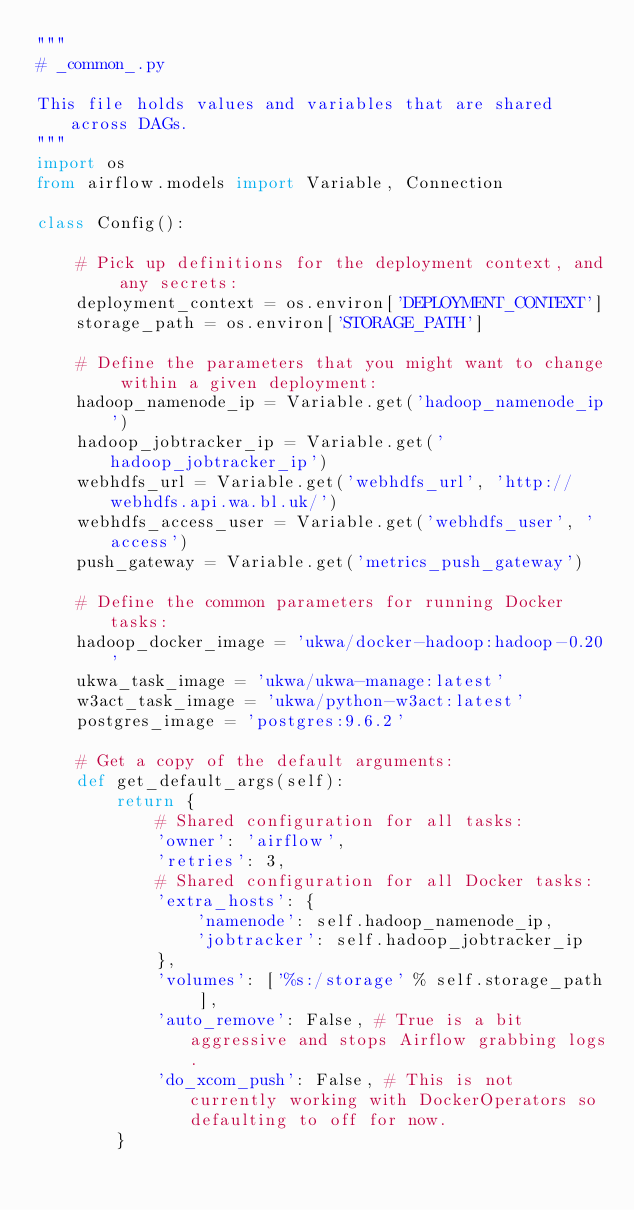<code> <loc_0><loc_0><loc_500><loc_500><_Python_>"""
# _common_.py

This file holds values and variables that are shared across DAGs.
""" 
import os
from airflow.models import Variable, Connection

class Config():

    # Pick up definitions for the deployment context, and any secrets:
    deployment_context = os.environ['DEPLOYMENT_CONTEXT']
    storage_path = os.environ['STORAGE_PATH']

    # Define the parameters that you might want to change within a given deployment:
    hadoop_namenode_ip = Variable.get('hadoop_namenode_ip')
    hadoop_jobtracker_ip = Variable.get('hadoop_jobtracker_ip')
    webhdfs_url = Variable.get('webhdfs_url', 'http://webhdfs.api.wa.bl.uk/')
    webhdfs_access_user = Variable.get('webhdfs_user', 'access')
    push_gateway = Variable.get('metrics_push_gateway')

    # Define the common parameters for running Docker tasks:
    hadoop_docker_image = 'ukwa/docker-hadoop:hadoop-0.20'
    ukwa_task_image = 'ukwa/ukwa-manage:latest'
    w3act_task_image = 'ukwa/python-w3act:latest'
    postgres_image = 'postgres:9.6.2'

    # Get a copy of the default arguments:
    def get_default_args(self):
        return {
            # Shared configuration for all tasks:
            'owner': 'airflow',
            'retries': 3,
            # Shared configuration for all Docker tasks:
            'extra_hosts': {
                'namenode': self.hadoop_namenode_ip,
                'jobtracker': self.hadoop_jobtracker_ip
            },
            'volumes': ['%s:/storage' % self.storage_path ],
            'auto_remove': False, # True is a bit aggressive and stops Airflow grabbing logs.
            'do_xcom_push': False, # This is not currently working with DockerOperators so defaulting to off for now.
        }   
</code> 